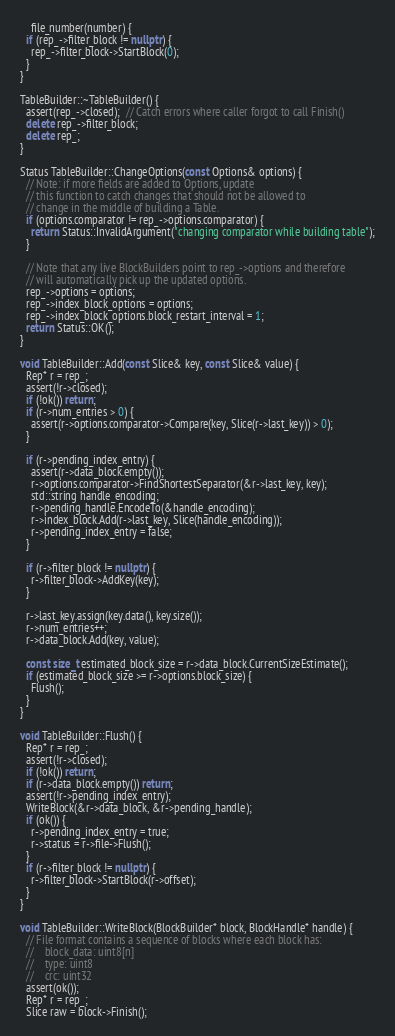<code> <loc_0><loc_0><loc_500><loc_500><_C++_>    file_number(number) {
  if (rep_->filter_block != nullptr) {
    rep_->filter_block->StartBlock(0);
  }
}

TableBuilder::~TableBuilder() {
  assert(rep_->closed);  // Catch errors where caller forgot to call Finish()
  delete rep_->filter_block;
  delete rep_;
}

Status TableBuilder::ChangeOptions(const Options& options) {
  // Note: if more fields are added to Options, update
  // this function to catch changes that should not be allowed to
  // change in the middle of building a Table.
  if (options.comparator != rep_->options.comparator) {
    return Status::InvalidArgument("changing comparator while building table");
  }

  // Note that any live BlockBuilders point to rep_->options and therefore
  // will automatically pick up the updated options.
  rep_->options = options;
  rep_->index_block_options = options;
  rep_->index_block_options.block_restart_interval = 1;
  return Status::OK();
}

void TableBuilder::Add(const Slice& key, const Slice& value) {
  Rep* r = rep_;
  assert(!r->closed);
  if (!ok()) return;
  if (r->num_entries > 0) {
    assert(r->options.comparator->Compare(key, Slice(r->last_key)) > 0);
  }

  if (r->pending_index_entry) {
    assert(r->data_block.empty());
    r->options.comparator->FindShortestSeparator(&r->last_key, key);
    std::string handle_encoding;
    r->pending_handle.EncodeTo(&handle_encoding);
    r->index_block.Add(r->last_key, Slice(handle_encoding));
    r->pending_index_entry = false;
  }

  if (r->filter_block != nullptr) {
    r->filter_block->AddKey(key);
  }

  r->last_key.assign(key.data(), key.size());
  r->num_entries++;
  r->data_block.Add(key, value);

  const size_t estimated_block_size = r->data_block.CurrentSizeEstimate();
  if (estimated_block_size >= r->options.block_size) {
    Flush();
  }
}

void TableBuilder::Flush() {
  Rep* r = rep_;
  assert(!r->closed);
  if (!ok()) return;
  if (r->data_block.empty()) return;
  assert(!r->pending_index_entry);
  WriteBlock(&r->data_block, &r->pending_handle);
  if (ok()) {
    r->pending_index_entry = true;
    r->status = r->file->Flush();
  }
  if (r->filter_block != nullptr) {
    r->filter_block->StartBlock(r->offset);
  }
}

void TableBuilder::WriteBlock(BlockBuilder* block, BlockHandle* handle) {
  // File format contains a sequence of blocks where each block has:
  //    block_data: uint8[n]
  //    type: uint8
  //    crc: uint32
  assert(ok());
  Rep* r = rep_;
  Slice raw = block->Finish();
</code> 